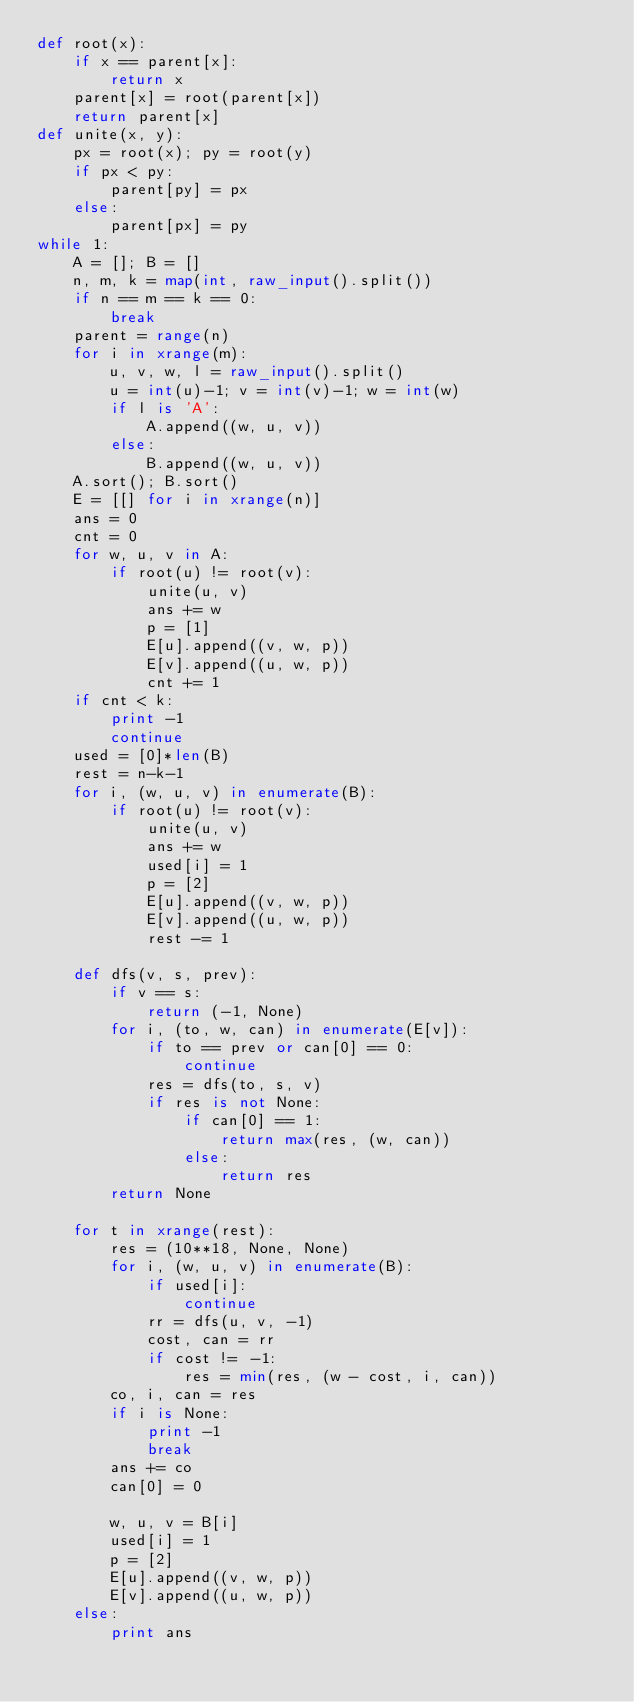<code> <loc_0><loc_0><loc_500><loc_500><_Python_>def root(x):
    if x == parent[x]:
        return x
    parent[x] = root(parent[x])
    return parent[x]
def unite(x, y):
    px = root(x); py = root(y)
    if px < py:
        parent[py] = px
    else:
        parent[px] = py
while 1:
    A = []; B = []
    n, m, k = map(int, raw_input().split())
    if n == m == k == 0:
        break
    parent = range(n)
    for i in xrange(m):
        u, v, w, l = raw_input().split()
        u = int(u)-1; v = int(v)-1; w = int(w)
        if l is 'A':
            A.append((w, u, v))
        else:
            B.append((w, u, v))
    A.sort(); B.sort()
    E = [[] for i in xrange(n)]
    ans = 0
    cnt = 0
    for w, u, v in A:
        if root(u) != root(v):
            unite(u, v)
            ans += w
            p = [1]
            E[u].append((v, w, p))
            E[v].append((u, w, p))
            cnt += 1
    if cnt < k:
        print -1
        continue
    used = [0]*len(B)
    rest = n-k-1
    for i, (w, u, v) in enumerate(B):
        if root(u) != root(v):
            unite(u, v)
            ans += w
            used[i] = 1
            p = [2]
            E[u].append((v, w, p))
            E[v].append((u, w, p))
            rest -= 1

    def dfs(v, s, prev):
        if v == s:
            return (-1, None)
        for i, (to, w, can) in enumerate(E[v]):
            if to == prev or can[0] == 0:
                continue
            res = dfs(to, s, v)
            if res is not None:
                if can[0] == 1:
                    return max(res, (w, can))
                else:
                    return res
        return None

    for t in xrange(rest):
        res = (10**18, None, None)
        for i, (w, u, v) in enumerate(B):
            if used[i]:
                continue
            rr = dfs(u, v, -1)
            cost, can = rr
            if cost != -1:
                res = min(res, (w - cost, i, can))
        co, i, can = res
        if i is None:
            print -1
            break
        ans += co
        can[0] = 0

        w, u, v = B[i]
        used[i] = 1
        p = [2]
        E[u].append((v, w, p))
        E[v].append((u, w, p))
    else:
        print ans</code> 